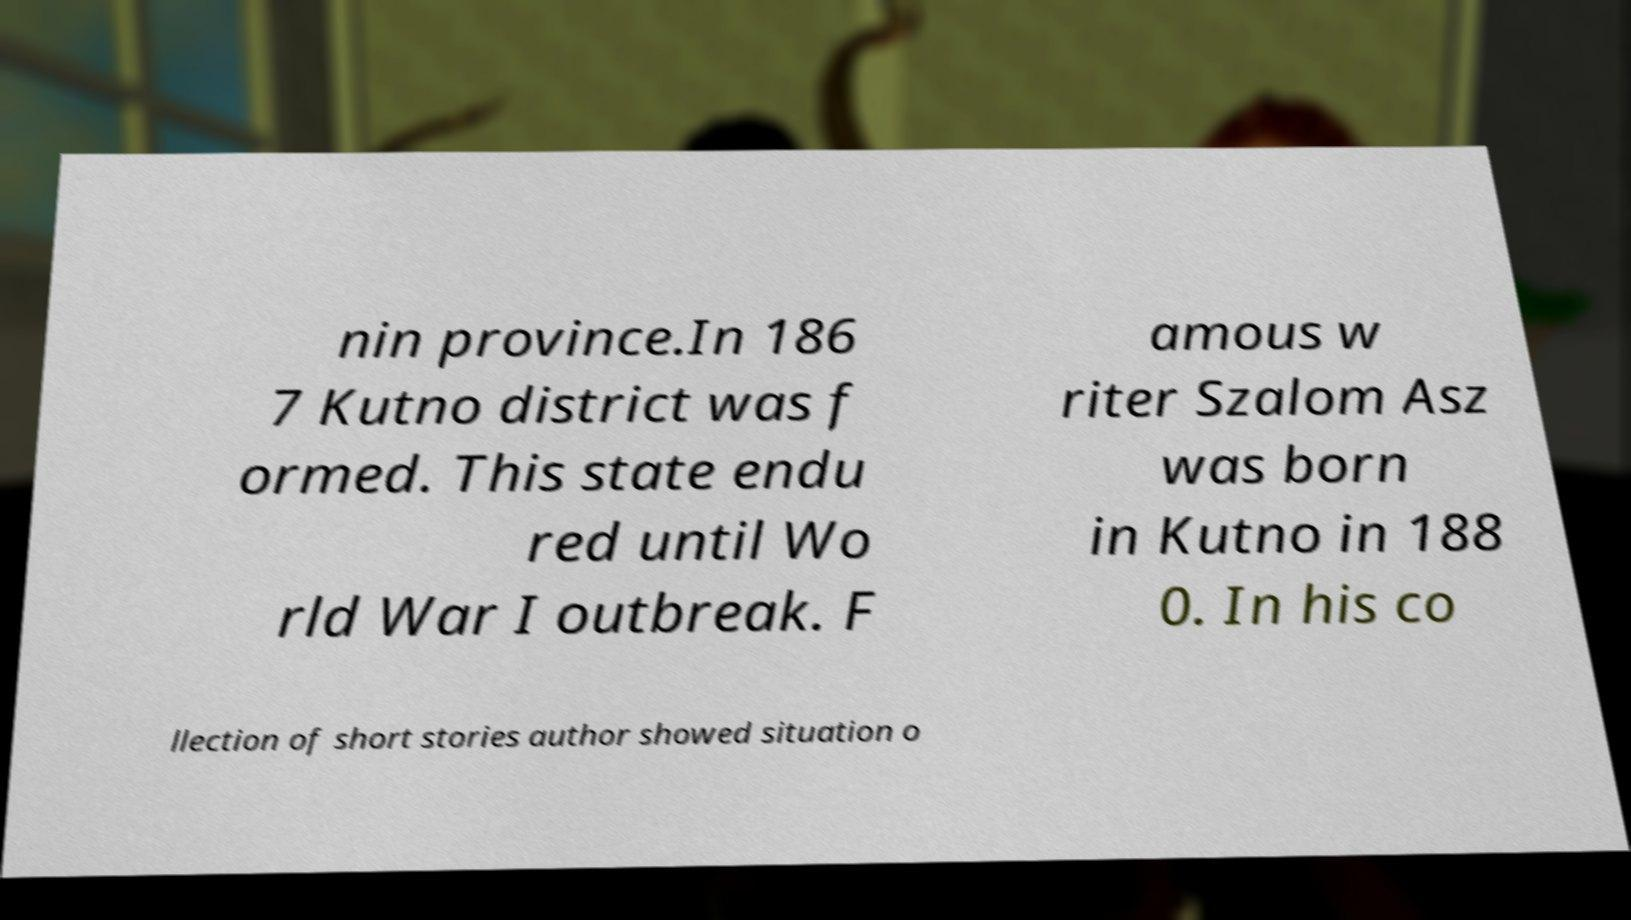I need the written content from this picture converted into text. Can you do that? nin province.In 186 7 Kutno district was f ormed. This state endu red until Wo rld War I outbreak. F amous w riter Szalom Asz was born in Kutno in 188 0. In his co llection of short stories author showed situation o 